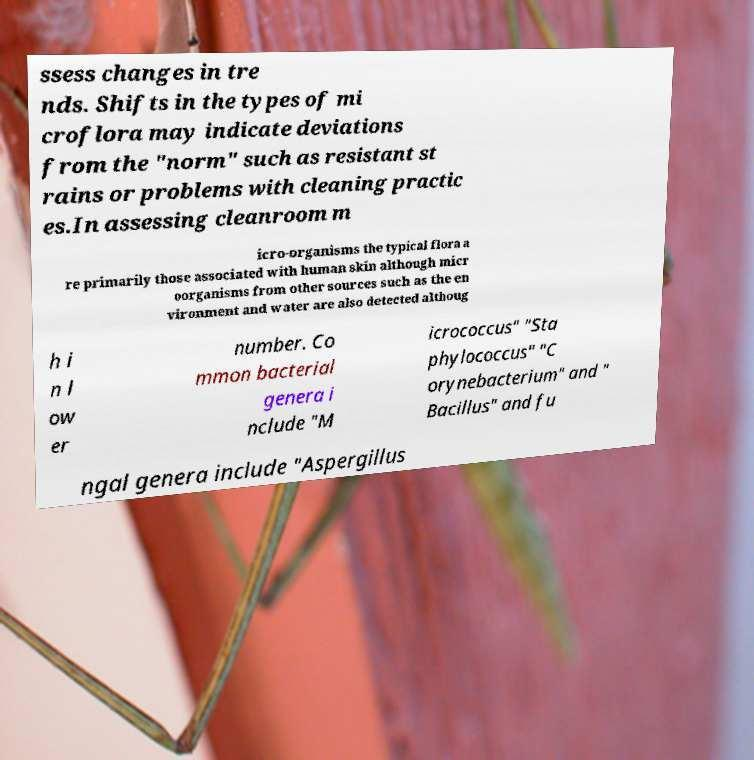What messages or text are displayed in this image? I need them in a readable, typed format. ssess changes in tre nds. Shifts in the types of mi croflora may indicate deviations from the "norm" such as resistant st rains or problems with cleaning practic es.In assessing cleanroom m icro-organisms the typical flora a re primarily those associated with human skin although micr oorganisms from other sources such as the en vironment and water are also detected althoug h i n l ow er number. Co mmon bacterial genera i nclude "M icrococcus" "Sta phylococcus" "C orynebacterium" and " Bacillus" and fu ngal genera include "Aspergillus 